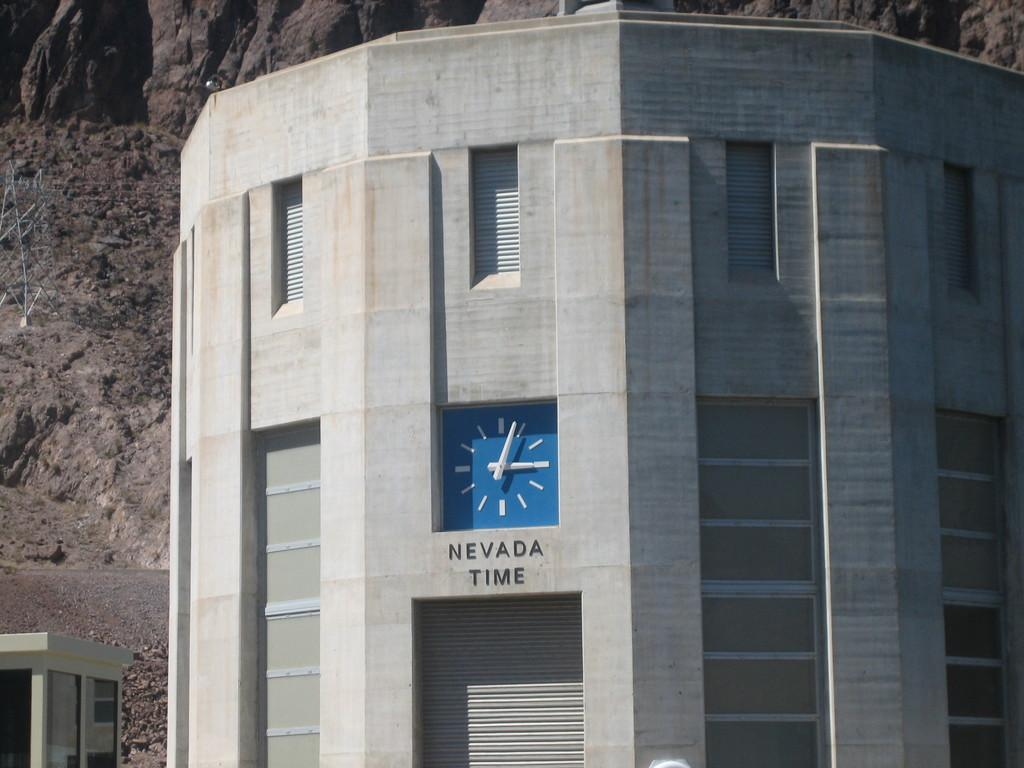<image>
Create a compact narrative representing the image presented. A blue clock labeled "Nevada Time" keeps time on a gray rounded structure. 